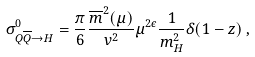<formula> <loc_0><loc_0><loc_500><loc_500>\sigma ^ { 0 } _ { Q \overline { Q } \to H } = \frac { \pi } { 6 } \frac { \overline { m } ^ { 2 } ( \mu ) } { v ^ { 2 } } \mu ^ { 2 \epsilon } \frac { 1 } { m _ { H } ^ { 2 } } \delta ( 1 - z ) \, ,</formula> 